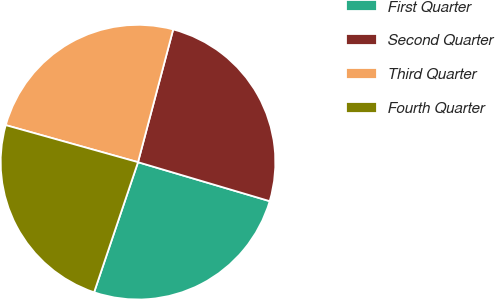<chart> <loc_0><loc_0><loc_500><loc_500><pie_chart><fcel>First Quarter<fcel>Second Quarter<fcel>Third Quarter<fcel>Fourth Quarter<nl><fcel>25.6%<fcel>25.46%<fcel>24.78%<fcel>24.17%<nl></chart> 